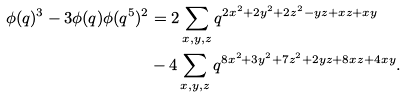Convert formula to latex. <formula><loc_0><loc_0><loc_500><loc_500>\phi ( q ) ^ { 3 } - 3 \phi ( q ) \phi ( q ^ { 5 } ) ^ { 2 } & = 2 \sum _ { x , y , z } q ^ { 2 x ^ { 2 } + 2 y ^ { 2 } + 2 z ^ { 2 } - y z + x z + x y } \\ & - 4 \sum _ { x , y , z } q ^ { 8 x ^ { 2 } + 3 y ^ { 2 } + 7 z ^ { 2 } + 2 y z + 8 x z + 4 x y } .</formula> 